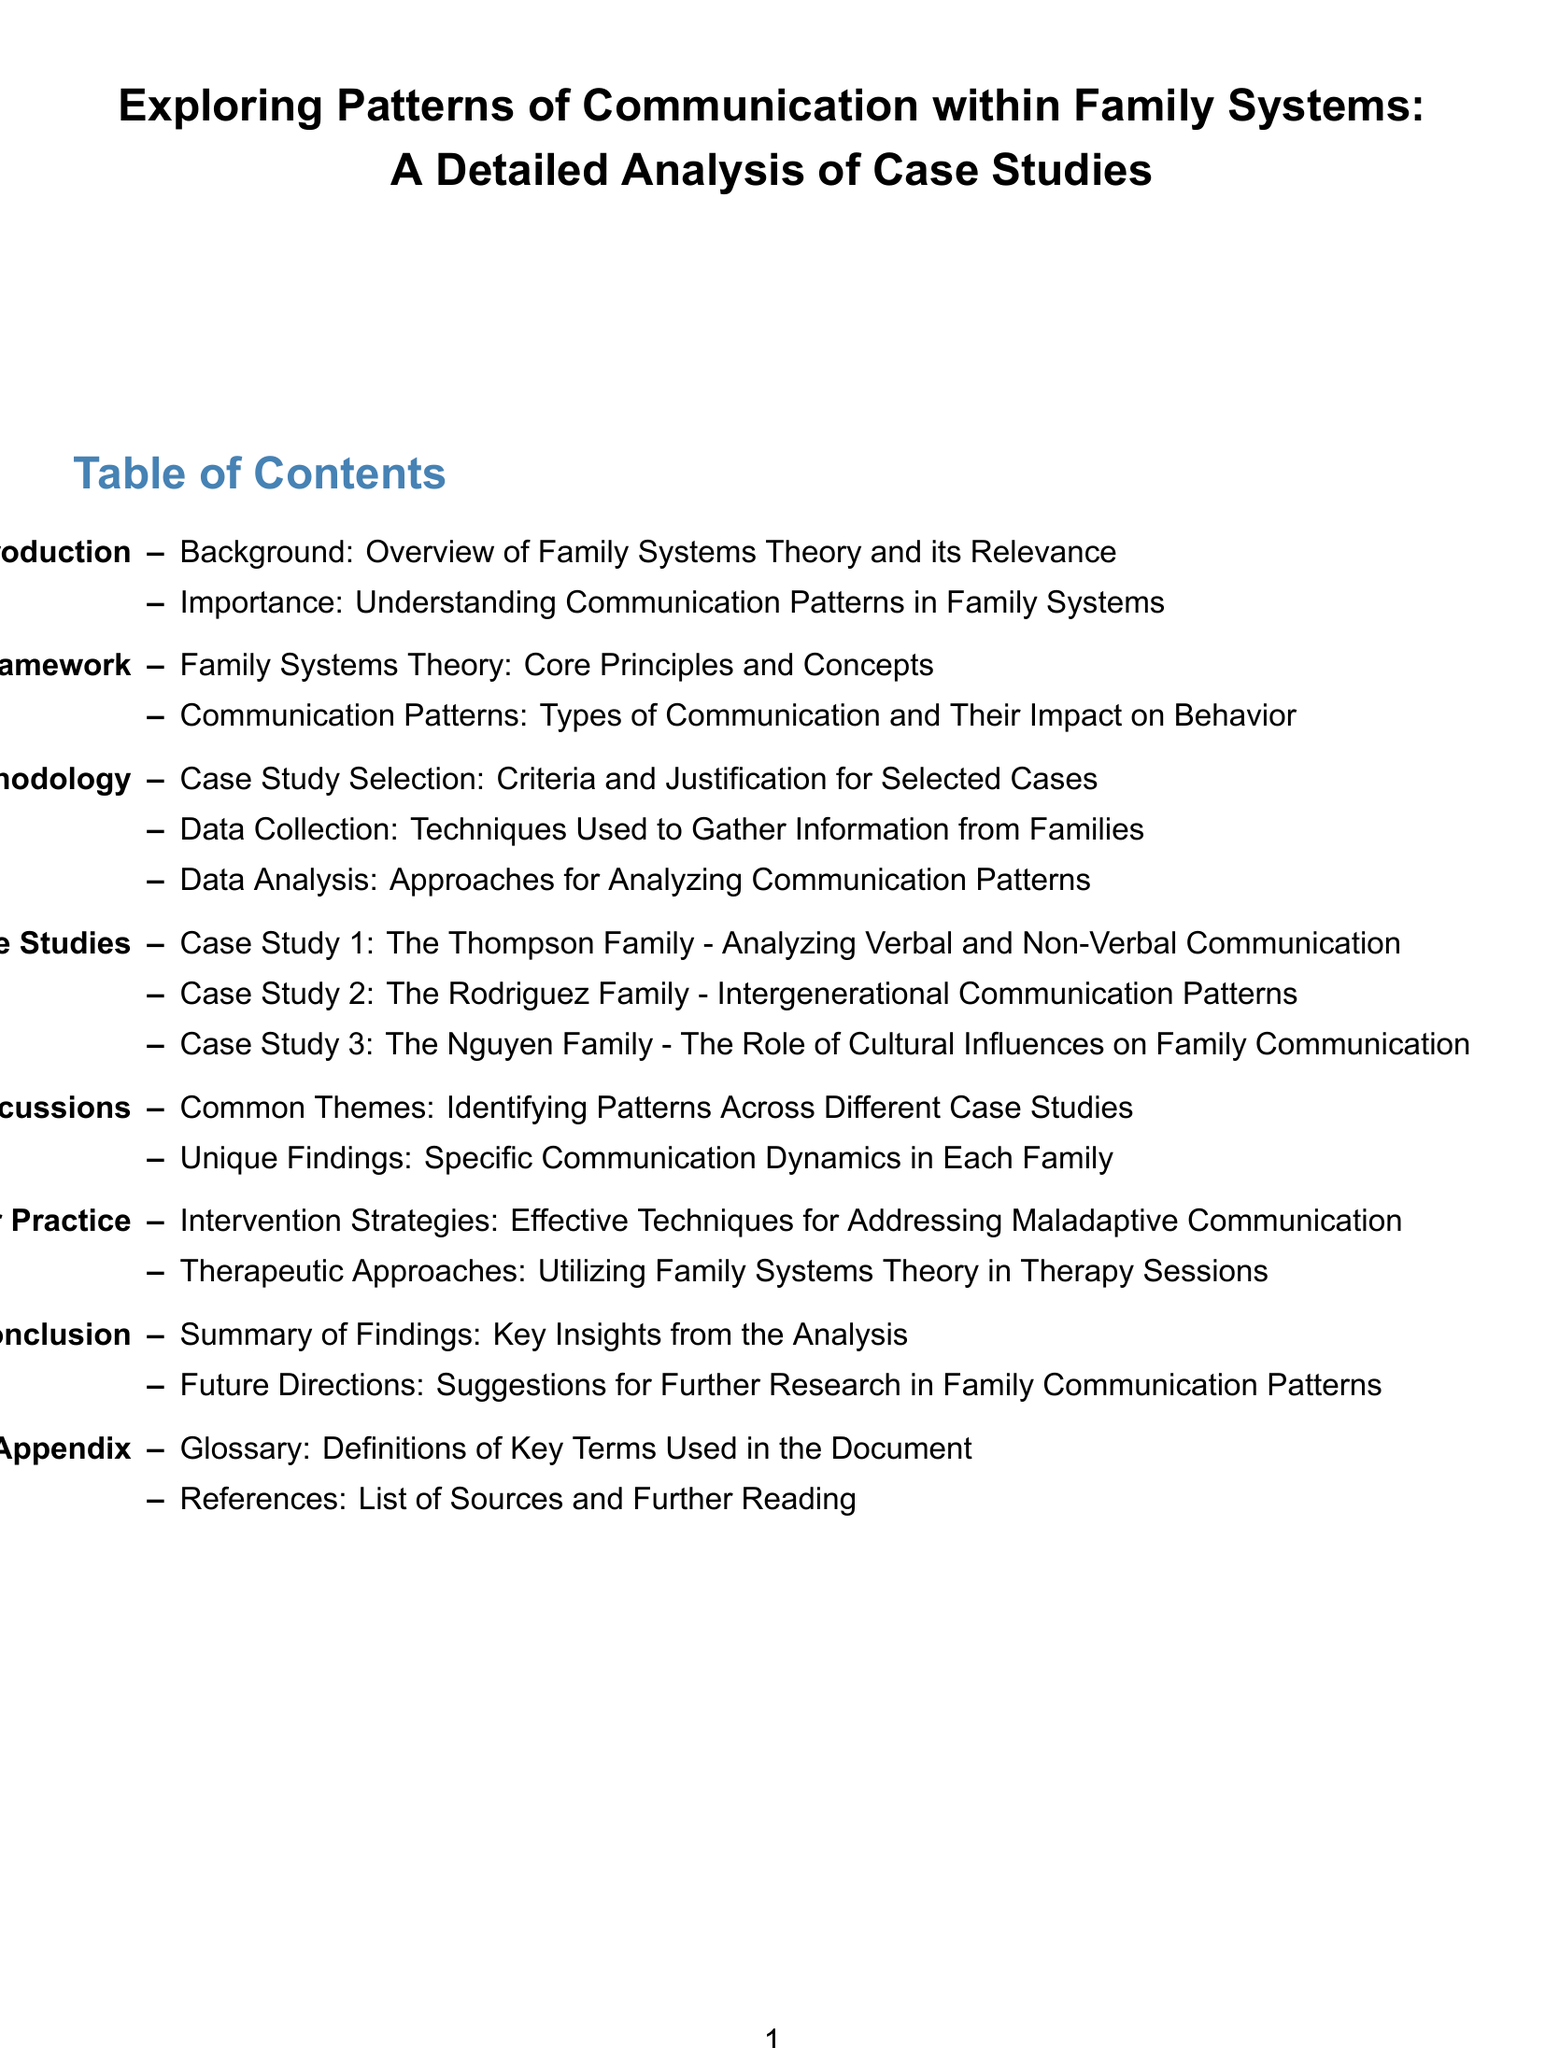What is the title of the document? The title summarizes the focus of the document, which is on communication patterns within family systems.
Answer: Exploring Patterns of Communication within Family Systems: A Detailed Analysis of Case Studies What chapter discusses case studies? This chapter contains specific instances that illustrate communication patterns and dynamics among families.
Answer: Chapter 3: Case Studies How many case studies are analyzed? The section enumerates the number of families examined in this analysis.
Answer: Three What is the focus of Chapter 2? This chapter outlines the methodology used for the research, including case selection and data collection methods.
Answer: Methodology Which family is associated with intergenerational communication patterns? This family’s study emphasizes how different generations communicate within the family system.
Answer: The Rodriguez Family What type of intervention strategies are mentioned? The document suggests approaches aimed at improving dysfunctional communication in family settings.
Answer: Effective Techniques for Addressing Maladaptive Communication What is included in the appendix? This section typically provides additional information or resources that support the main content of the document.
Answer: Glossary and References What are the common themes discussed in Chapter 4? This chapter aims to consolidate findings from various case studies to identify prevalent patterns.
Answer: Identifying Patterns Across Different Case Studies What principle is foundational to the document? This theory provides the guiding framework for analyzing family communication and behavior.
Answer: Family Systems Theory 